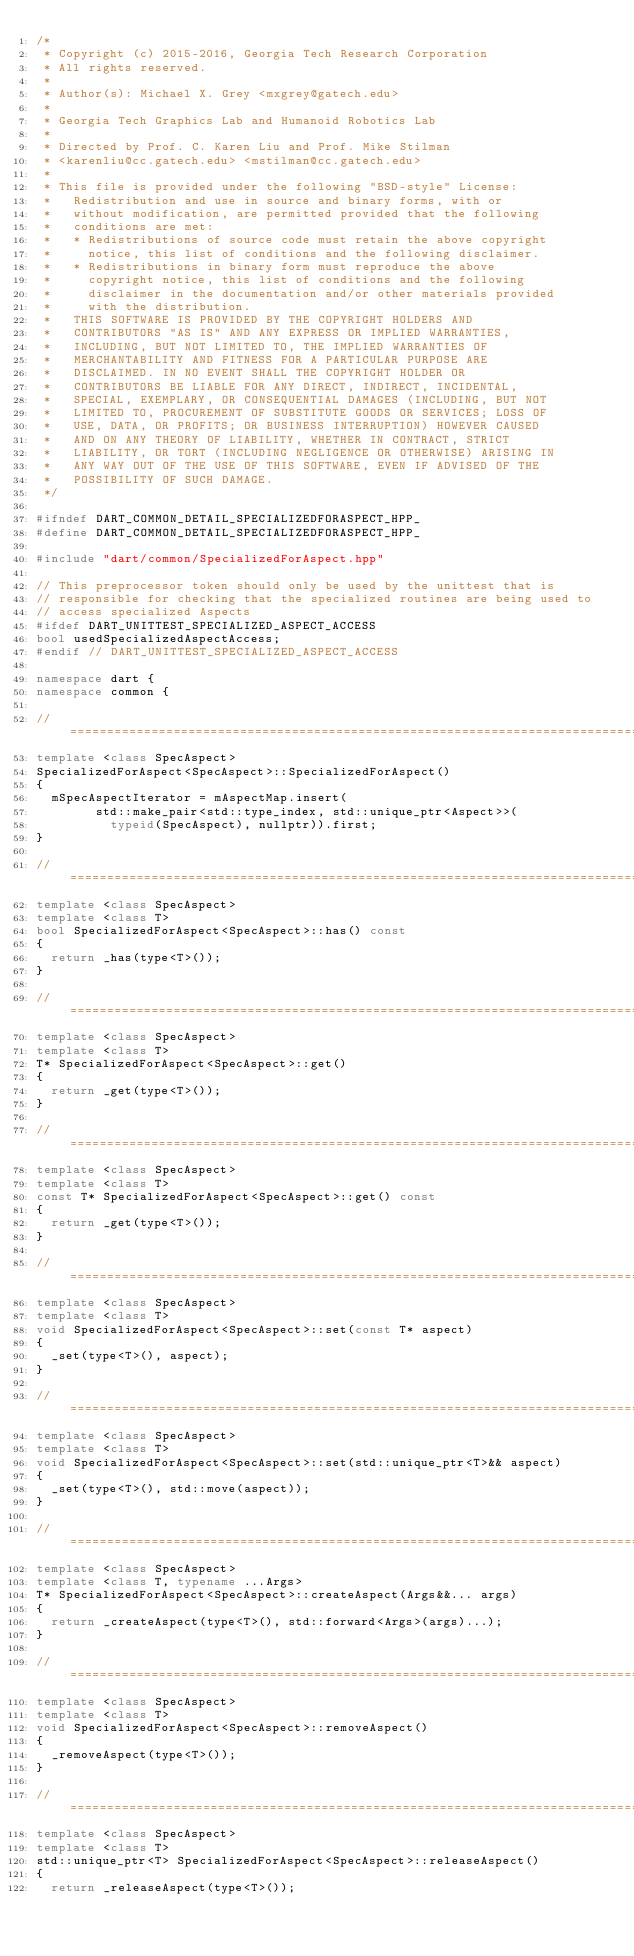Convert code to text. <code><loc_0><loc_0><loc_500><loc_500><_C++_>/*
 * Copyright (c) 2015-2016, Georgia Tech Research Corporation
 * All rights reserved.
 *
 * Author(s): Michael X. Grey <mxgrey@gatech.edu>
 *
 * Georgia Tech Graphics Lab and Humanoid Robotics Lab
 *
 * Directed by Prof. C. Karen Liu and Prof. Mike Stilman
 * <karenliu@cc.gatech.edu> <mstilman@cc.gatech.edu>
 *
 * This file is provided under the following "BSD-style" License:
 *   Redistribution and use in source and binary forms, with or
 *   without modification, are permitted provided that the following
 *   conditions are met:
 *   * Redistributions of source code must retain the above copyright
 *     notice, this list of conditions and the following disclaimer.
 *   * Redistributions in binary form must reproduce the above
 *     copyright notice, this list of conditions and the following
 *     disclaimer in the documentation and/or other materials provided
 *     with the distribution.
 *   THIS SOFTWARE IS PROVIDED BY THE COPYRIGHT HOLDERS AND
 *   CONTRIBUTORS "AS IS" AND ANY EXPRESS OR IMPLIED WARRANTIES,
 *   INCLUDING, BUT NOT LIMITED TO, THE IMPLIED WARRANTIES OF
 *   MERCHANTABILITY AND FITNESS FOR A PARTICULAR PURPOSE ARE
 *   DISCLAIMED. IN NO EVENT SHALL THE COPYRIGHT HOLDER OR
 *   CONTRIBUTORS BE LIABLE FOR ANY DIRECT, INDIRECT, INCIDENTAL,
 *   SPECIAL, EXEMPLARY, OR CONSEQUENTIAL DAMAGES (INCLUDING, BUT NOT
 *   LIMITED TO, PROCUREMENT OF SUBSTITUTE GOODS OR SERVICES; LOSS OF
 *   USE, DATA, OR PROFITS; OR BUSINESS INTERRUPTION) HOWEVER CAUSED
 *   AND ON ANY THEORY OF LIABILITY, WHETHER IN CONTRACT, STRICT
 *   LIABILITY, OR TORT (INCLUDING NEGLIGENCE OR OTHERWISE) ARISING IN
 *   ANY WAY OUT OF THE USE OF THIS SOFTWARE, EVEN IF ADVISED OF THE
 *   POSSIBILITY OF SUCH DAMAGE.
 */

#ifndef DART_COMMON_DETAIL_SPECIALIZEDFORASPECT_HPP_
#define DART_COMMON_DETAIL_SPECIALIZEDFORASPECT_HPP_

#include "dart/common/SpecializedForAspect.hpp"

// This preprocessor token should only be used by the unittest that is
// responsible for checking that the specialized routines are being used to
// access specialized Aspects
#ifdef DART_UNITTEST_SPECIALIZED_ASPECT_ACCESS
bool usedSpecializedAspectAccess;
#endif // DART_UNITTEST_SPECIALIZED_ASPECT_ACCESS

namespace dart {
namespace common {

//==============================================================================
template <class SpecAspect>
SpecializedForAspect<SpecAspect>::SpecializedForAspect()
{
  mSpecAspectIterator = mAspectMap.insert(
        std::make_pair<std::type_index, std::unique_ptr<Aspect>>(
          typeid(SpecAspect), nullptr)).first;
}

//==============================================================================
template <class SpecAspect>
template <class T>
bool SpecializedForAspect<SpecAspect>::has() const
{
  return _has(type<T>());
}

//==============================================================================
template <class SpecAspect>
template <class T>
T* SpecializedForAspect<SpecAspect>::get()
{
  return _get(type<T>());
}

//==============================================================================
template <class SpecAspect>
template <class T>
const T* SpecializedForAspect<SpecAspect>::get() const
{
  return _get(type<T>());
}

//==============================================================================
template <class SpecAspect>
template <class T>
void SpecializedForAspect<SpecAspect>::set(const T* aspect)
{
  _set(type<T>(), aspect);
}

//==============================================================================
template <class SpecAspect>
template <class T>
void SpecializedForAspect<SpecAspect>::set(std::unique_ptr<T>&& aspect)
{
  _set(type<T>(), std::move(aspect));
}

//==============================================================================
template <class SpecAspect>
template <class T, typename ...Args>
T* SpecializedForAspect<SpecAspect>::createAspect(Args&&... args)
{
  return _createAspect(type<T>(), std::forward<Args>(args)...);
}

//==============================================================================
template <class SpecAspect>
template <class T>
void SpecializedForAspect<SpecAspect>::removeAspect()
{
  _removeAspect(type<T>());
}

//==============================================================================
template <class SpecAspect>
template <class T>
std::unique_ptr<T> SpecializedForAspect<SpecAspect>::releaseAspect()
{
  return _releaseAspect(type<T>());</code> 